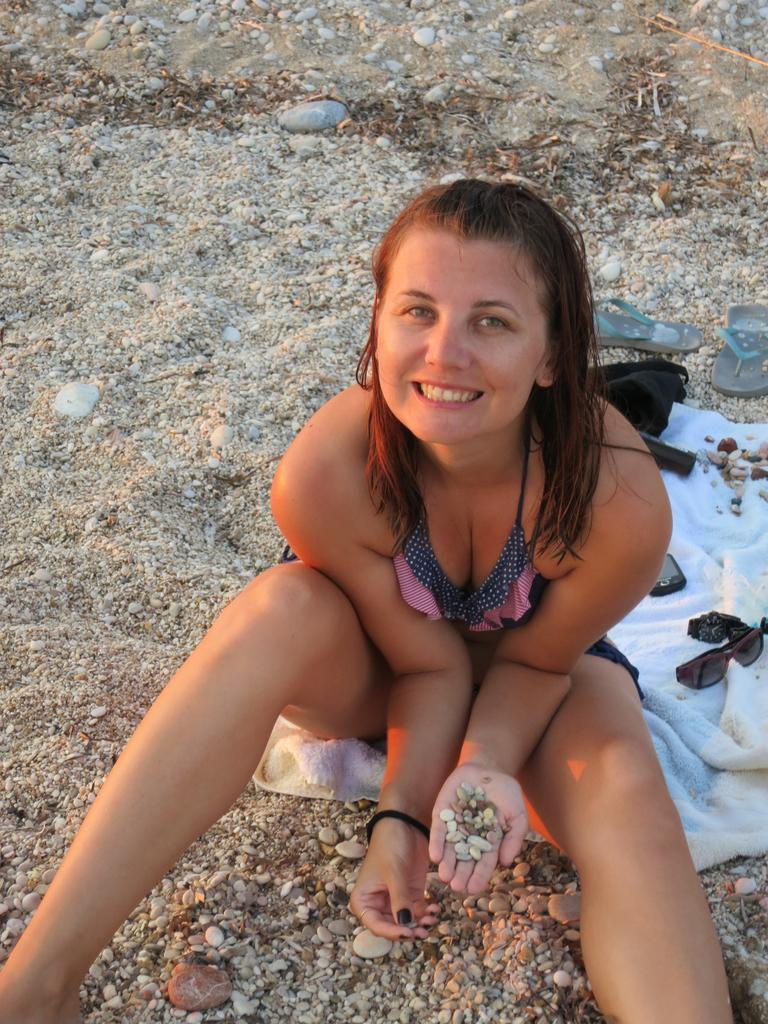Who is the main subject in the image? There is a girl in the image. What is the girl sitting on? The girl is sitting on a cloth. Where is the cloth located? The cloth is on the sand. What objects can be seen besides the girl and the cloth? There are glasses and slippers in the image. What type of milk is being served in the glasses in the image? There is no milk present in the image; only glasses are visible. 